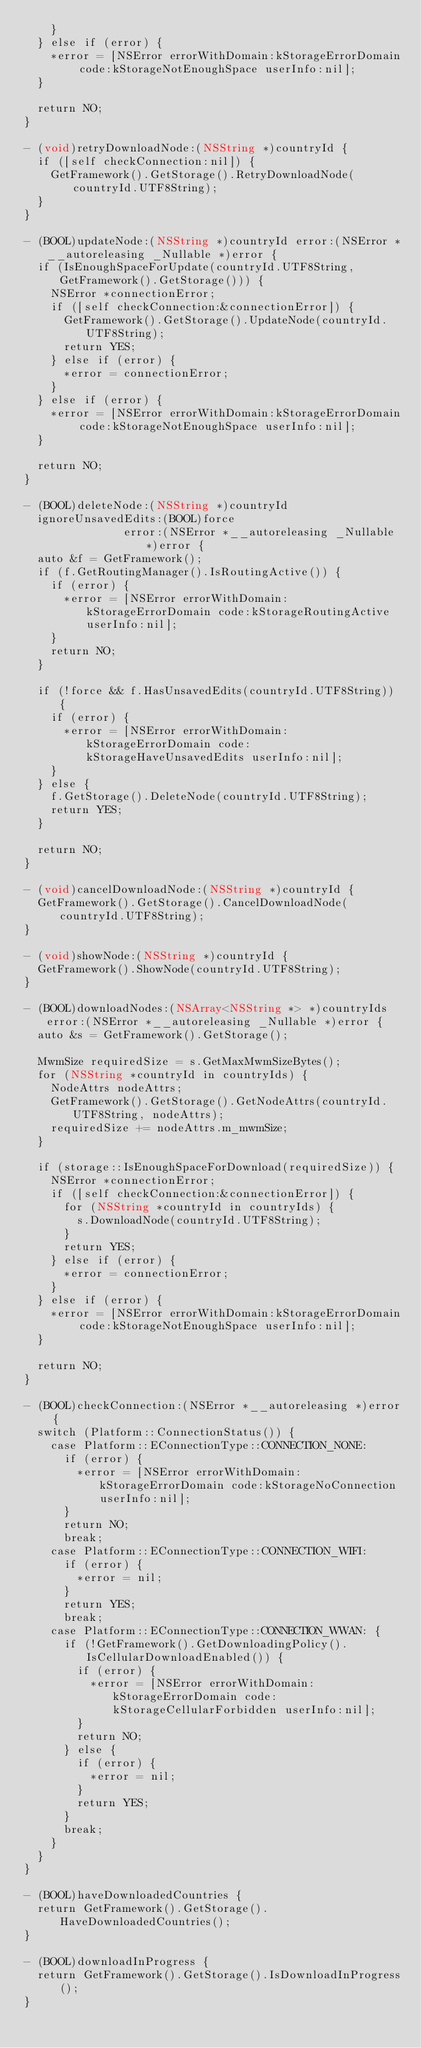Convert code to text. <code><loc_0><loc_0><loc_500><loc_500><_ObjectiveC_>    }
  } else if (error) {
    *error = [NSError errorWithDomain:kStorageErrorDomain code:kStorageNotEnoughSpace userInfo:nil];
  }

  return NO;
}

- (void)retryDownloadNode:(NSString *)countryId {
  if ([self checkConnection:nil]) {
    GetFramework().GetStorage().RetryDownloadNode(countryId.UTF8String);
  }
}

- (BOOL)updateNode:(NSString *)countryId error:(NSError *__autoreleasing _Nullable *)error {
  if (IsEnoughSpaceForUpdate(countryId.UTF8String, GetFramework().GetStorage())) {
    NSError *connectionError;
    if ([self checkConnection:&connectionError]) {
      GetFramework().GetStorage().UpdateNode(countryId.UTF8String);
      return YES;
    } else if (error) {
      *error = connectionError;
    }
  } else if (error) {
    *error = [NSError errorWithDomain:kStorageErrorDomain code:kStorageNotEnoughSpace userInfo:nil];
  }

  return NO;
}

- (BOOL)deleteNode:(NSString *)countryId
  ignoreUnsavedEdits:(BOOL)force
               error:(NSError *__autoreleasing _Nullable *)error {
  auto &f = GetFramework();
  if (f.GetRoutingManager().IsRoutingActive()) {
    if (error) {
      *error = [NSError errorWithDomain:kStorageErrorDomain code:kStorageRoutingActive userInfo:nil];
    }
    return NO;
  }

  if (!force && f.HasUnsavedEdits(countryId.UTF8String)) {
    if (error) {
      *error = [NSError errorWithDomain:kStorageErrorDomain code:kStorageHaveUnsavedEdits userInfo:nil];
    }
  } else {
    f.GetStorage().DeleteNode(countryId.UTF8String);
    return YES;
  }

  return NO;
}

- (void)cancelDownloadNode:(NSString *)countryId {
  GetFramework().GetStorage().CancelDownloadNode(countryId.UTF8String);
}

- (void)showNode:(NSString *)countryId {
  GetFramework().ShowNode(countryId.UTF8String);
}

- (BOOL)downloadNodes:(NSArray<NSString *> *)countryIds error:(NSError *__autoreleasing _Nullable *)error {
  auto &s = GetFramework().GetStorage();

  MwmSize requiredSize = s.GetMaxMwmSizeBytes();
  for (NSString *countryId in countryIds) {
    NodeAttrs nodeAttrs;
    GetFramework().GetStorage().GetNodeAttrs(countryId.UTF8String, nodeAttrs);
    requiredSize += nodeAttrs.m_mwmSize;
  }

  if (storage::IsEnoughSpaceForDownload(requiredSize)) {
    NSError *connectionError;
    if ([self checkConnection:&connectionError]) {
      for (NSString *countryId in countryIds) {
        s.DownloadNode(countryId.UTF8String);
      }
      return YES;
    } else if (error) {
      *error = connectionError;
    }
  } else if (error) {
    *error = [NSError errorWithDomain:kStorageErrorDomain code:kStorageNotEnoughSpace userInfo:nil];
  }

  return NO;
}

- (BOOL)checkConnection:(NSError *__autoreleasing *)error {
  switch (Platform::ConnectionStatus()) {
    case Platform::EConnectionType::CONNECTION_NONE:
      if (error) {
        *error = [NSError errorWithDomain:kStorageErrorDomain code:kStorageNoConnection userInfo:nil];
      }
      return NO;
      break;
    case Platform::EConnectionType::CONNECTION_WIFI:
      if (error) {
        *error = nil;
      }
      return YES;
      break;
    case Platform::EConnectionType::CONNECTION_WWAN: {
      if (!GetFramework().GetDownloadingPolicy().IsCellularDownloadEnabled()) {
        if (error) {
          *error = [NSError errorWithDomain:kStorageErrorDomain code:kStorageCellularForbidden userInfo:nil];
        }
        return NO;
      } else {
        if (error) {
          *error = nil;
        }
        return YES;
      }
      break;
    }
  }
}

- (BOOL)haveDownloadedCountries {
  return GetFramework().GetStorage().HaveDownloadedCountries();
}

- (BOOL)downloadInProgress {
  return GetFramework().GetStorage().IsDownloadInProgress();
}
</code> 